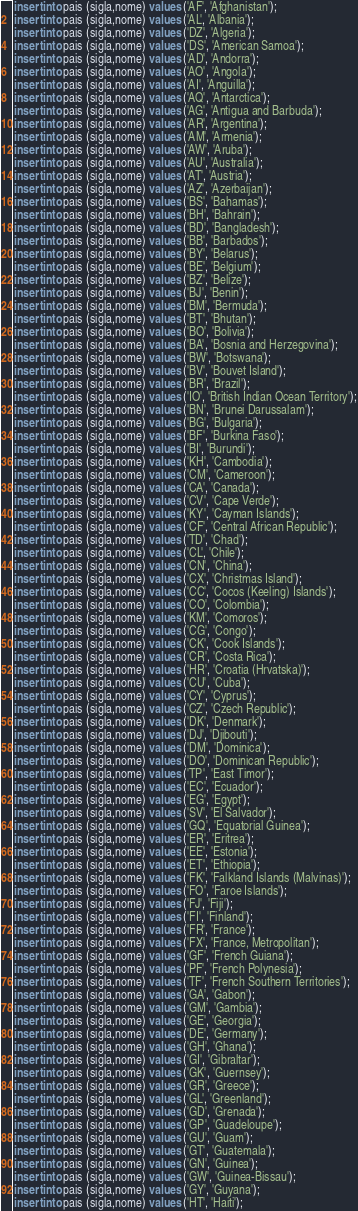<code> <loc_0><loc_0><loc_500><loc_500><_SQL_>insert into pais (sigla,nome) values ('AF', 'Afghanistan');
insert into pais (sigla,nome) values ('AL', 'Albania');
insert into pais (sigla,nome) values ('DZ', 'Algeria');
insert into pais (sigla,nome) values ('DS', 'American Samoa');
insert into pais (sigla,nome) values ('AD', 'Andorra');
insert into pais (sigla,nome) values ('AO', 'Angola');
insert into pais (sigla,nome) values ('AI', 'Anguilla');
insert into pais (sigla,nome) values ('AQ', 'Antarctica');
insert into pais (sigla,nome) values ('AG', 'Antigua and Barbuda');
insert into pais (sigla,nome) values ('AR', 'Argentina');
insert into pais (sigla,nome) values ('AM', 'Armenia');
insert into pais (sigla,nome) values ('AW', 'Aruba');
insert into pais (sigla,nome) values ('AU', 'Australia');
insert into pais (sigla,nome) values ('AT', 'Austria');
insert into pais (sigla,nome) values ('AZ', 'Azerbaijan');
insert into pais (sigla,nome) values ('BS', 'Bahamas');
insert into pais (sigla,nome) values ('BH', 'Bahrain');
insert into pais (sigla,nome) values ('BD', 'Bangladesh');
insert into pais (sigla,nome) values ('BB', 'Barbados');
insert into pais (sigla,nome) values ('BY', 'Belarus');
insert into pais (sigla,nome) values ('BE', 'Belgium');
insert into pais (sigla,nome) values ('BZ', 'Belize');
insert into pais (sigla,nome) values ('BJ', 'Benin');
insert into pais (sigla,nome) values ('BM', 'Bermuda');
insert into pais (sigla,nome) values ('BT', 'Bhutan');
insert into pais (sigla,nome) values ('BO', 'Bolivia');
insert into pais (sigla,nome) values ('BA', 'Bosnia and Herzegovina');
insert into pais (sigla,nome) values ('BW', 'Botswana');
insert into pais (sigla,nome) values ('BV', 'Bouvet Island');
insert into pais (sigla,nome) values ('BR', 'Brazil');
insert into pais (sigla,nome) values ('IO', 'British Indian Ocean Territory');
insert into pais (sigla,nome) values ('BN', 'Brunei Darussalam');
insert into pais (sigla,nome) values ('BG', 'Bulgaria');
insert into pais (sigla,nome) values ('BF', 'Burkina Faso');
insert into pais (sigla,nome) values ('BI', 'Burundi');
insert into pais (sigla,nome) values ('KH', 'Cambodia');
insert into pais (sigla,nome) values ('CM', 'Cameroon');
insert into pais (sigla,nome) values ('CA', 'Canada');
insert into pais (sigla,nome) values ('CV', 'Cape Verde');
insert into pais (sigla,nome) values ('KY', 'Cayman Islands');
insert into pais (sigla,nome) values ('CF', 'Central African Republic');
insert into pais (sigla,nome) values ('TD', 'Chad');
insert into pais (sigla,nome) values ('CL', 'Chile');
insert into pais (sigla,nome) values ('CN', 'China');
insert into pais (sigla,nome) values ('CX', 'Christmas Island');
insert into pais (sigla,nome) values ('CC', 'Cocos (Keeling) Islands');
insert into pais (sigla,nome) values ('CO', 'Colombia');
insert into pais (sigla,nome) values ('KM', 'Comoros');
insert into pais (sigla,nome) values ('CG', 'Congo');
insert into pais (sigla,nome) values ('CK', 'Cook Islands');
insert into pais (sigla,nome) values ('CR', 'Costa Rica');
insert into pais (sigla,nome) values ('HR', 'Croatia (Hrvatska)');
insert into pais (sigla,nome) values ('CU', 'Cuba');
insert into pais (sigla,nome) values ('CY', 'Cyprus');
insert into pais (sigla,nome) values ('CZ', 'Czech Republic');
insert into pais (sigla,nome) values ('DK', 'Denmark');
insert into pais (sigla,nome) values ('DJ', 'Djibouti');
insert into pais (sigla,nome) values ('DM', 'Dominica');
insert into pais (sigla,nome) values ('DO', 'Dominican Republic');
insert into pais (sigla,nome) values ('TP', 'East Timor');
insert into pais (sigla,nome) values ('EC', 'Ecuador');
insert into pais (sigla,nome) values ('EG', 'Egypt');
insert into pais (sigla,nome) values ('SV', 'El Salvador');
insert into pais (sigla,nome) values ('GQ', 'Equatorial Guinea');
insert into pais (sigla,nome) values ('ER', 'Eritrea');
insert into pais (sigla,nome) values ('EE', 'Estonia');
insert into pais (sigla,nome) values ('ET', 'Ethiopia');
insert into pais (sigla,nome) values ('FK', 'Falkland Islands (Malvinas)');
insert into pais (sigla,nome) values ('FO', 'Faroe Islands');
insert into pais (sigla,nome) values ('FJ', 'Fiji');
insert into pais (sigla,nome) values ('FI', 'Finland');
insert into pais (sigla,nome) values ('FR', 'France');
insert into pais (sigla,nome) values ('FX', 'France, Metropolitan');
insert into pais (sigla,nome) values ('GF', 'French Guiana');
insert into pais (sigla,nome) values ('PF', 'French Polynesia');
insert into pais (sigla,nome) values ('TF', 'French Southern Territories');
insert into pais (sigla,nome) values ('GA', 'Gabon');
insert into pais (sigla,nome) values ('GM', 'Gambia');
insert into pais (sigla,nome) values ('GE', 'Georgia');
insert into pais (sigla,nome) values ('DE', 'Germany');
insert into pais (sigla,nome) values ('GH', 'Ghana');
insert into pais (sigla,nome) values ('GI', 'Gibraltar');
insert into pais (sigla,nome) values ('GK', 'Guernsey');
insert into pais (sigla,nome) values ('GR', 'Greece');
insert into pais (sigla,nome) values ('GL', 'Greenland');
insert into pais (sigla,nome) values ('GD', 'Grenada');
insert into pais (sigla,nome) values ('GP', 'Guadeloupe');
insert into pais (sigla,nome) values ('GU', 'Guam');
insert into pais (sigla,nome) values ('GT', 'Guatemala');
insert into pais (sigla,nome) values ('GN', 'Guinea');
insert into pais (sigla,nome) values ('GW', 'Guinea-Bissau');
insert into pais (sigla,nome) values ('GY', 'Guyana');
insert into pais (sigla,nome) values ('HT', 'Haiti');</code> 